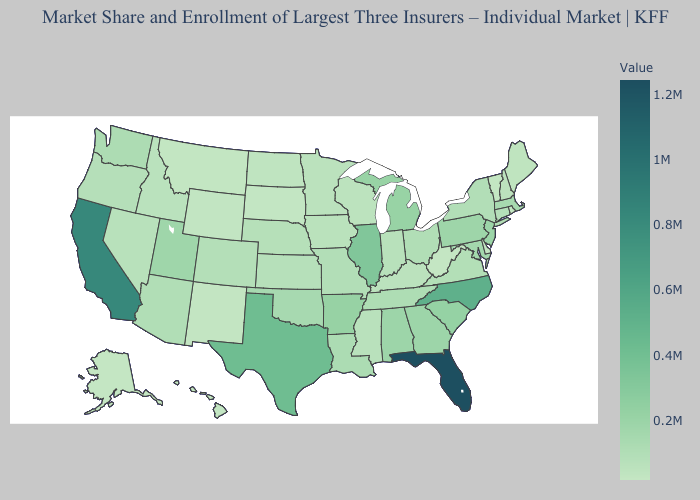Among the states that border Illinois , does Kentucky have the lowest value?
Give a very brief answer. No. Does Florida have the highest value in the USA?
Short answer required. Yes. Which states have the lowest value in the Northeast?
Give a very brief answer. Vermont. Does the map have missing data?
Keep it brief. No. 